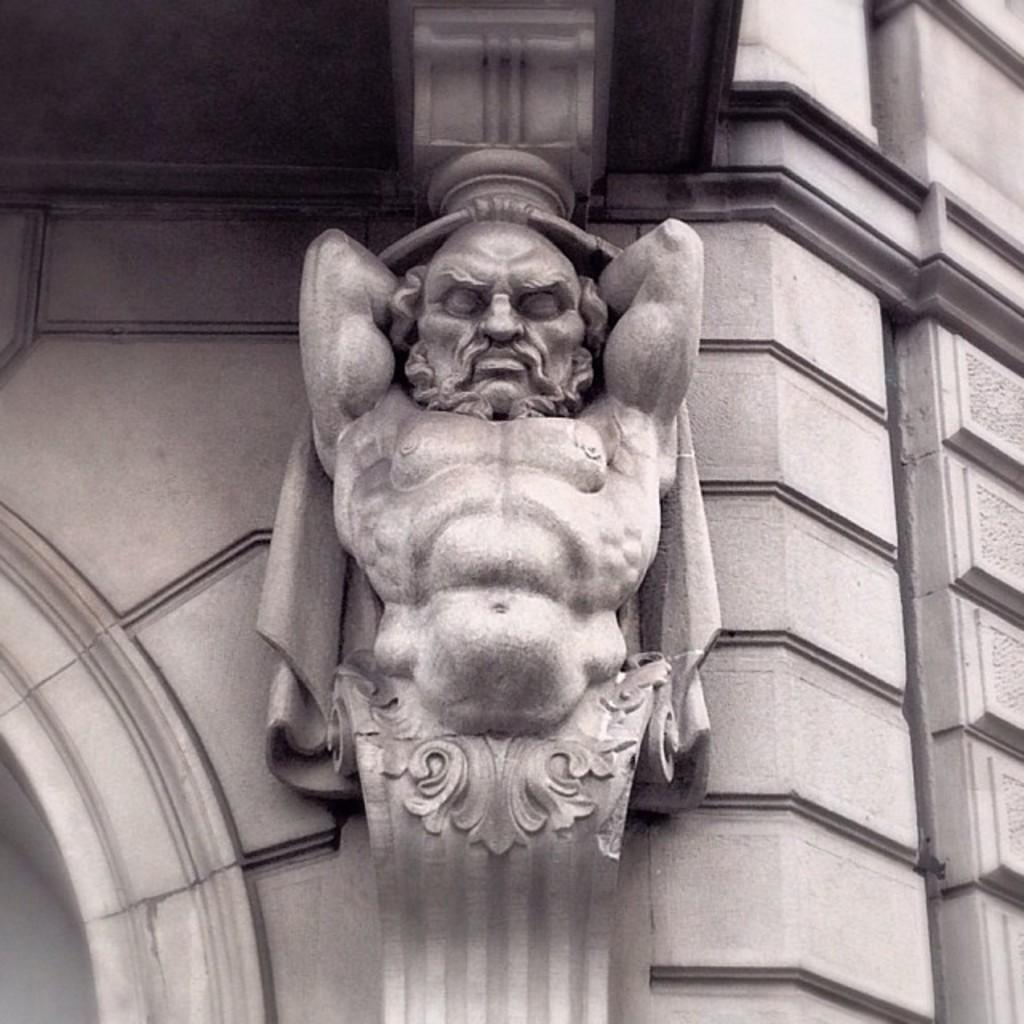What is the main subject of the image? There is a sculpture in the image. Where is the sculpture located? The sculpture is on the wall of a building. What type of pizzas are being taught in the image? There is no mention of pizzas or teaching in the image; it features a sculpture on the wall of a building. 